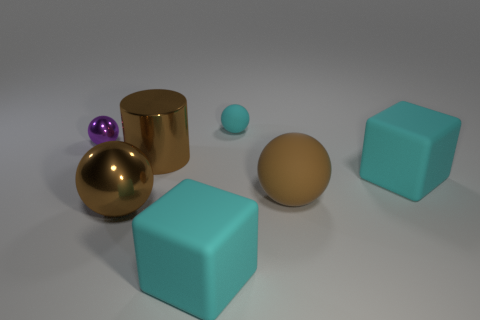Add 3 purple metal things. How many objects exist? 10 Subtract all large brown metal balls. How many balls are left? 3 Subtract all brown balls. How many balls are left? 2 Subtract all cubes. How many objects are left? 5 Subtract all blue cubes. How many brown balls are left? 2 Subtract 4 balls. How many balls are left? 0 Subtract all gray blocks. Subtract all cyan spheres. How many blocks are left? 2 Subtract all big metallic things. Subtract all large yellow rubber cubes. How many objects are left? 5 Add 6 big metal cylinders. How many big metal cylinders are left? 7 Add 2 small brown things. How many small brown things exist? 2 